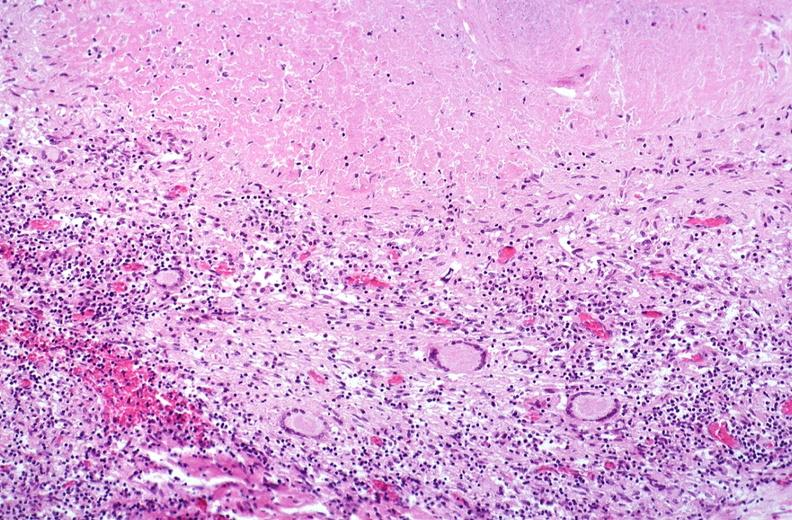s respiratory present?
Answer the question using a single word or phrase. Yes 